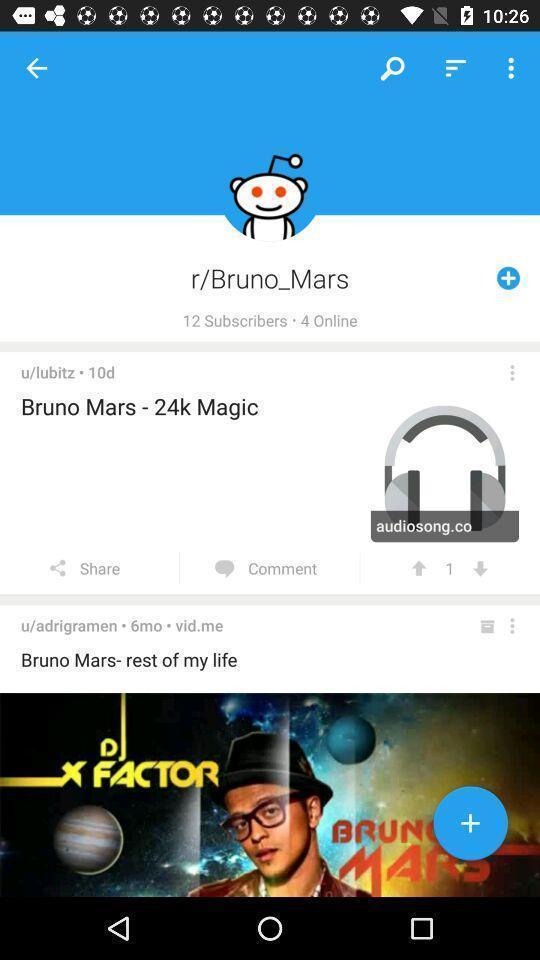Provide a description of this screenshot. Screen page displaying a profile. 